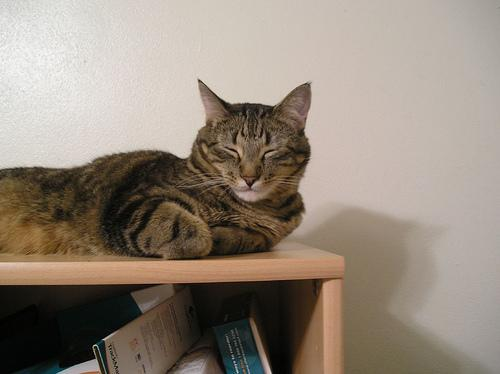What is the cat on top of? bookshelf 